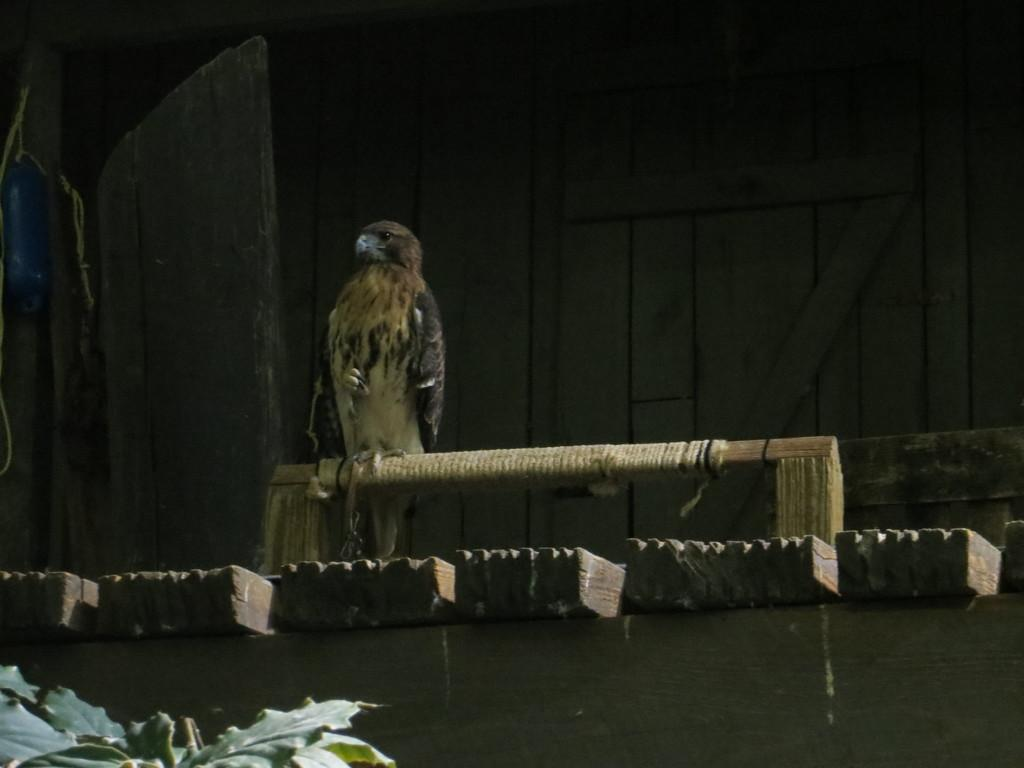What is present in the image besides the wall? There is a plant and a bird on a wooden object in the image. Can you describe the bird in the image? The bird has brown and black colors. What is the background color of the image? The background of the image is black. What type of canvas is the bird using to paint in the image? There is no canvas or painting activity present in the image. Can you tell me how many chins the bird has in the image? The bird does not have a chin, as it is a bird and not a human. 